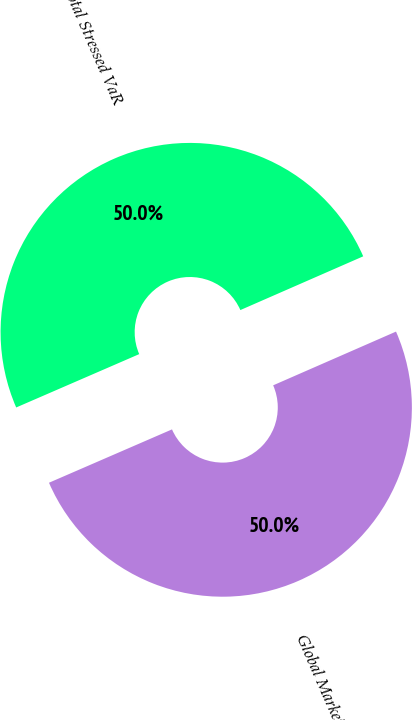Convert chart to OTSL. <chart><loc_0><loc_0><loc_500><loc_500><pie_chart><fcel>Global Markets<fcel>Total Stressed VaR<nl><fcel>50.05%<fcel>49.95%<nl></chart> 